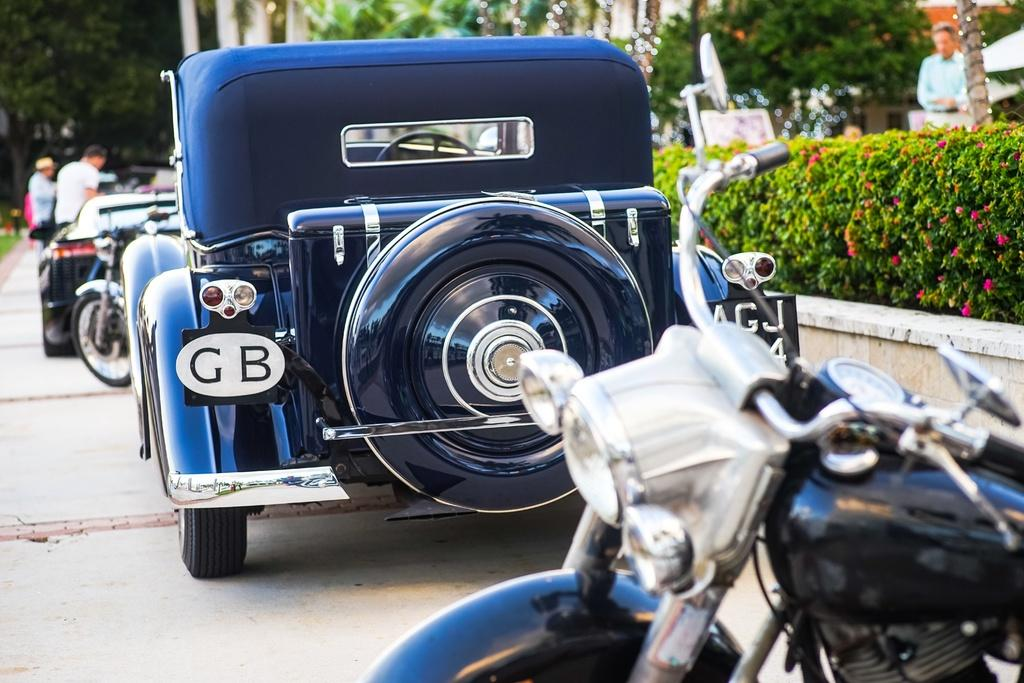What can be seen in the middle of the image? There are vehicles on the road in the center of the image. Can you describe the people in the image? There are people in the image, but their specific actions or appearances are not mentioned in the provided facts. What is on the right side of the image? There is a hedge on the right side of the image. What can be seen in the background of the image? There are trees in the background of the image. Where is the bubble located in the image? There is no bubble present in the image. What type of ball can be seen in the image? There is no ball present in the image. 